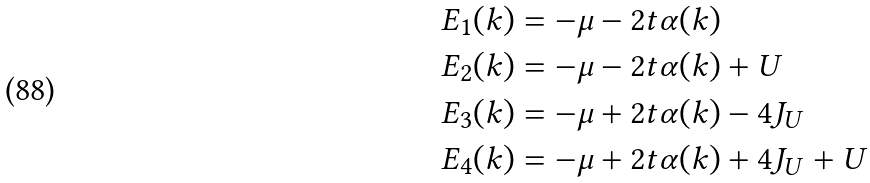<formula> <loc_0><loc_0><loc_500><loc_500>& E _ { 1 } ( k ) = - \mu - 2 t \alpha ( k ) \\ & E _ { 2 } ( k ) = - \mu - 2 t \alpha ( k ) + U \\ & E _ { 3 } ( k ) = - \mu + 2 t \alpha ( k ) - 4 J _ { U } \\ & E _ { 4 } ( k ) = - \mu + 2 t \alpha ( k ) + 4 J _ { U } + U</formula> 